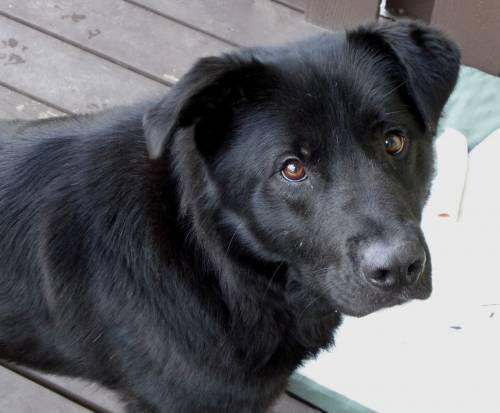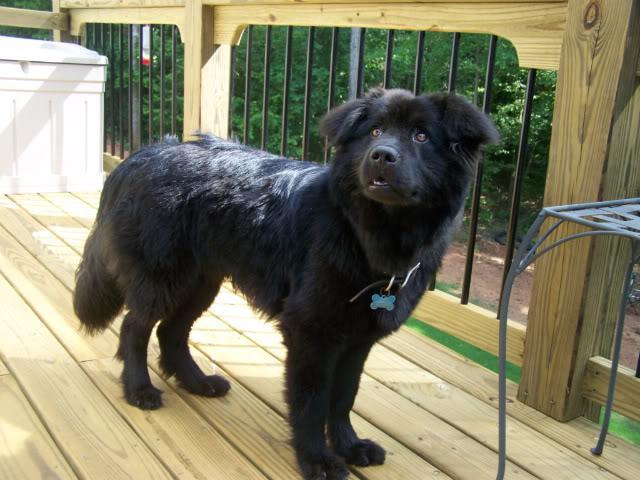The first image is the image on the left, the second image is the image on the right. Analyze the images presented: Is the assertion "Each image contains one solid black dog, and all dogs have their bodies turned rightward." valid? Answer yes or no. Yes. 